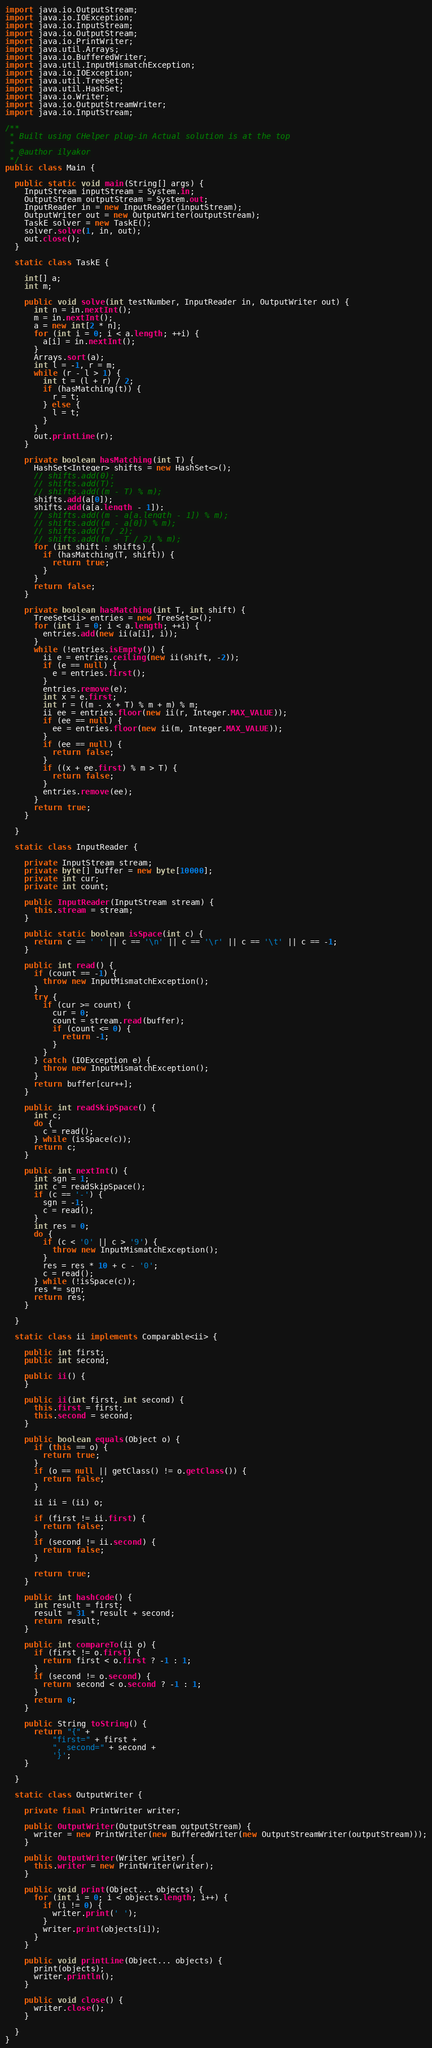<code> <loc_0><loc_0><loc_500><loc_500><_Java_>import java.io.OutputStream;
import java.io.IOException;
import java.io.InputStream;
import java.io.OutputStream;
import java.io.PrintWriter;
import java.util.Arrays;
import java.io.BufferedWriter;
import java.util.InputMismatchException;
import java.io.IOException;
import java.util.TreeSet;
import java.util.HashSet;
import java.io.Writer;
import java.io.OutputStreamWriter;
import java.io.InputStream;

/**
 * Built using CHelper plug-in Actual solution is at the top
 *
 * @author ilyakor
 */
public class Main {

  public static void main(String[] args) {
    InputStream inputStream = System.in;
    OutputStream outputStream = System.out;
    InputReader in = new InputReader(inputStream);
    OutputWriter out = new OutputWriter(outputStream);
    TaskE solver = new TaskE();
    solver.solve(1, in, out);
    out.close();
  }

  static class TaskE {

    int[] a;
    int m;

    public void solve(int testNumber, InputReader in, OutputWriter out) {
      int n = in.nextInt();
      m = in.nextInt();
      a = new int[2 * n];
      for (int i = 0; i < a.length; ++i) {
        a[i] = in.nextInt();
      }
      Arrays.sort(a);
      int l = -1, r = m;
      while (r - l > 1) {
        int t = (l + r) / 2;
        if (hasMatching(t)) {
          r = t;
        } else {
          l = t;
        }
      }
      out.printLine(r);
    }

    private boolean hasMatching(int T) {
      HashSet<Integer> shifts = new HashSet<>();
      // shifts.add(0);
      // shifts.add(T);
      // shifts.add((m - T) % m);
      shifts.add(a[0]);
      shifts.add(a[a.length - 1]);
      // shifts.add((m - a[a.length - 1]) % m);
      // shifts.add((m - a[0]) % m);
      // shifts.add(T / 2);
      // shifts.add((m - T / 2) % m);
      for (int shift : shifts) {
        if (hasMatching(T, shift)) {
          return true;
        }
      }
      return false;
    }

    private boolean hasMatching(int T, int shift) {
      TreeSet<ii> entries = new TreeSet<>();
      for (int i = 0; i < a.length; ++i) {
        entries.add(new ii(a[i], i));
      }
      while (!entries.isEmpty()) {
        ii e = entries.ceiling(new ii(shift, -2));
        if (e == null) {
          e = entries.first();
        }
        entries.remove(e);
        int x = e.first;
        int r = ((m - x + T) % m + m) % m;
        ii ee = entries.floor(new ii(r, Integer.MAX_VALUE));
        if (ee == null) {
          ee = entries.floor(new ii(m, Integer.MAX_VALUE));
        }
        if (ee == null) {
          return false;
        }
        if ((x + ee.first) % m > T) {
          return false;
        }
        entries.remove(ee);
      }
      return true;
    }

  }

  static class InputReader {

    private InputStream stream;
    private byte[] buffer = new byte[10000];
    private int cur;
    private int count;

    public InputReader(InputStream stream) {
      this.stream = stream;
    }

    public static boolean isSpace(int c) {
      return c == ' ' || c == '\n' || c == '\r' || c == '\t' || c == -1;
    }

    public int read() {
      if (count == -1) {
        throw new InputMismatchException();
      }
      try {
        if (cur >= count) {
          cur = 0;
          count = stream.read(buffer);
          if (count <= 0) {
            return -1;
          }
        }
      } catch (IOException e) {
        throw new InputMismatchException();
      }
      return buffer[cur++];
    }

    public int readSkipSpace() {
      int c;
      do {
        c = read();
      } while (isSpace(c));
      return c;
    }

    public int nextInt() {
      int sgn = 1;
      int c = readSkipSpace();
      if (c == '-') {
        sgn = -1;
        c = read();
      }
      int res = 0;
      do {
        if (c < '0' || c > '9') {
          throw new InputMismatchException();
        }
        res = res * 10 + c - '0';
        c = read();
      } while (!isSpace(c));
      res *= sgn;
      return res;
    }

  }

  static class ii implements Comparable<ii> {

    public int first;
    public int second;

    public ii() {
    }

    public ii(int first, int second) {
      this.first = first;
      this.second = second;
    }

    public boolean equals(Object o) {
      if (this == o) {
        return true;
      }
      if (o == null || getClass() != o.getClass()) {
        return false;
      }

      ii ii = (ii) o;

      if (first != ii.first) {
        return false;
      }
      if (second != ii.second) {
        return false;
      }

      return true;
    }

    public int hashCode() {
      int result = first;
      result = 31 * result + second;
      return result;
    }

    public int compareTo(ii o) {
      if (first != o.first) {
        return first < o.first ? -1 : 1;
      }
      if (second != o.second) {
        return second < o.second ? -1 : 1;
      }
      return 0;
    }

    public String toString() {
      return "{" +
          "first=" + first +
          ", second=" + second +
          '}';
    }

  }

  static class OutputWriter {

    private final PrintWriter writer;

    public OutputWriter(OutputStream outputStream) {
      writer = new PrintWriter(new BufferedWriter(new OutputStreamWriter(outputStream)));
    }

    public OutputWriter(Writer writer) {
      this.writer = new PrintWriter(writer);
    }

    public void print(Object... objects) {
      for (int i = 0; i < objects.length; i++) {
        if (i != 0) {
          writer.print(' ');
        }
        writer.print(objects[i]);
      }
    }

    public void printLine(Object... objects) {
      print(objects);
      writer.println();
    }

    public void close() {
      writer.close();
    }

  }
}

</code> 